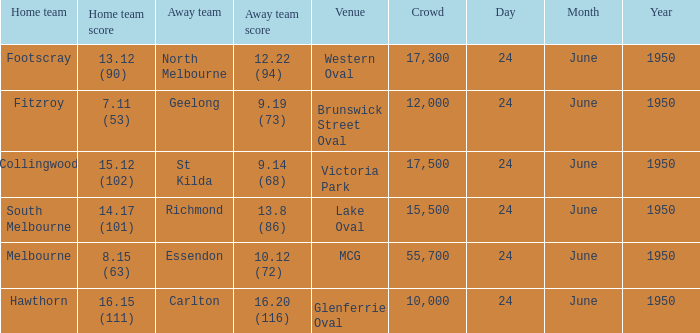Who was the home team for the game where North Melbourne was the away team? Footscray. 